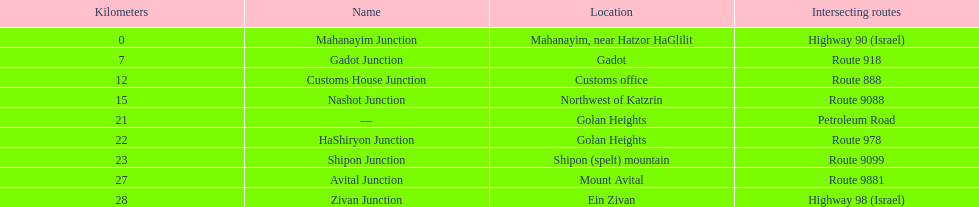What are all of the junction names? Mahanayim Junction, Gadot Junction, Customs House Junction, Nashot Junction, —, HaShiryon Junction, Shipon Junction, Avital Junction, Zivan Junction. What are their locations in kilometers? 0, 7, 12, 15, 21, 22, 23, 27, 28. Between shipon and avital, whicih is nashot closer to? Shipon Junction. 